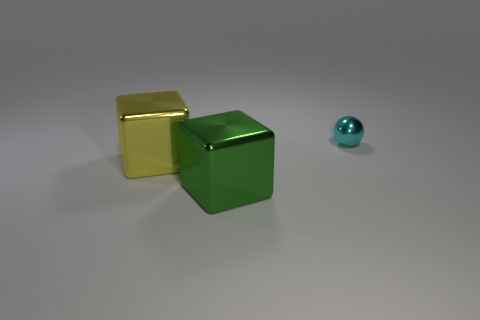Is the number of green cubes that are in front of the tiny metal sphere less than the number of cyan metal objects?
Ensure brevity in your answer.  No. How many small cyan objects are there?
Ensure brevity in your answer.  1. Does the large green thing have the same shape as the large yellow object?
Offer a very short reply. Yes. There is a shiny block that is behind the large metallic thing in front of the large yellow metallic thing; what size is it?
Offer a terse response. Large. Is there a thing that has the same size as the yellow metallic cube?
Your answer should be compact. Yes. Does the metal object left of the big green metallic thing have the same size as the shiny sphere to the right of the large green metallic object?
Give a very brief answer. No. What shape is the large shiny object that is in front of the large shiny block behind the green metallic block?
Offer a very short reply. Cube. There is a large yellow metallic block; what number of metallic cubes are to the right of it?
Make the answer very short. 1. The tiny thing that is made of the same material as the large green cube is what color?
Offer a terse response. Cyan. There is a cyan metal ball; does it have the same size as the cube on the left side of the green object?
Provide a short and direct response. No. 